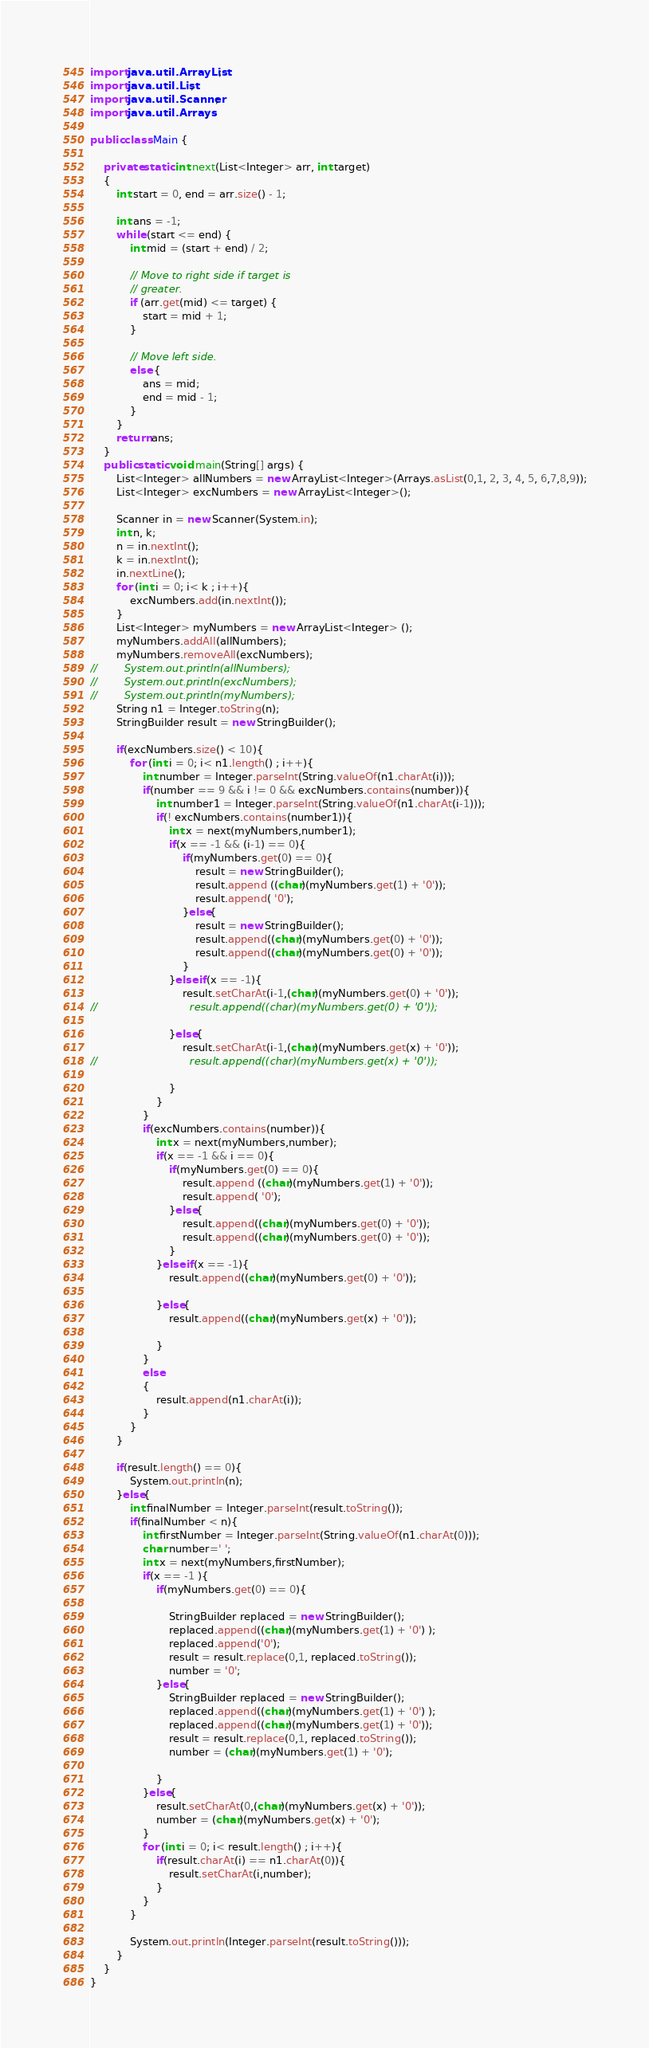Convert code to text. <code><loc_0><loc_0><loc_500><loc_500><_Java_>import java.util.ArrayList;
import java.util.List;
import java.util.Scanner;
import java.util.Arrays;

public class Main {

    private static int next(List<Integer> arr, int target)
    {
        int start = 0, end = arr.size() - 1;

        int ans = -1;
        while (start <= end) {
            int mid = (start + end) / 2;

            // Move to right side if target is
            // greater.
            if (arr.get(mid) <= target) {
                start = mid + 1;
            }

            // Move left side.
            else {
                ans = mid;
                end = mid - 1;
            }
        }
        return ans;
    }
    public static void main(String[] args) {
        List<Integer> allNumbers = new ArrayList<Integer>(Arrays.asList(0,1, 2, 3, 4, 5, 6,7,8,9));
        List<Integer> excNumbers = new ArrayList<Integer>();

        Scanner in = new Scanner(System.in);
        int n, k;
        n = in.nextInt();
        k = in.nextInt();
        in.nextLine();
        for (int i = 0; i< k ; i++){
            excNumbers.add(in.nextInt());
        }
        List<Integer> myNumbers = new ArrayList<Integer> ();
        myNumbers.addAll(allNumbers);
        myNumbers.removeAll(excNumbers);
//        System.out.println(allNumbers);
//        System.out.println(excNumbers);
//        System.out.println(myNumbers);
        String n1 = Integer.toString(n);
        StringBuilder result = new StringBuilder();

        if(excNumbers.size() < 10){
            for (int i = 0; i< n1.length() ; i++){
                int number = Integer.parseInt(String.valueOf(n1.charAt(i)));
                if(number == 9 && i != 0 && excNumbers.contains(number)){
                    int number1 = Integer.parseInt(String.valueOf(n1.charAt(i-1)));
                    if(! excNumbers.contains(number1)){
                        int x = next(myNumbers,number1);
                        if(x == -1 && (i-1) == 0){
                            if(myNumbers.get(0) == 0){
                                result = new StringBuilder();
                                result.append ((char)(myNumbers.get(1) + '0'));
                                result.append( '0');
                            }else{
                                result = new StringBuilder();
                                result.append((char)(myNumbers.get(0) + '0'));
                                result.append((char)(myNumbers.get(0) + '0'));
                            }
                        }else if(x == -1){
                            result.setCharAt(i-1,(char)(myNumbers.get(0) + '0'));
//                            result.append((char)(myNumbers.get(0) + '0'));

                        }else{
                            result.setCharAt(i-1,(char)(myNumbers.get(x) + '0'));
//                            result.append((char)(myNumbers.get(x) + '0'));

                        }
                    }
                }
                if(excNumbers.contains(number)){
                    int x = next(myNumbers,number);
                    if(x == -1 && i == 0){
                        if(myNumbers.get(0) == 0){
                            result.append ((char)(myNumbers.get(1) + '0'));
                            result.append( '0');
                        }else{
                            result.append((char)(myNumbers.get(0) + '0'));
                            result.append((char)(myNumbers.get(0) + '0'));
                        }
                    }else if(x == -1){
                        result.append((char)(myNumbers.get(0) + '0'));

                    }else{
                        result.append((char)(myNumbers.get(x) + '0'));

                    }
                }
                else
                {
                    result.append(n1.charAt(i));
                }
            }
        }

        if(result.length() == 0){
            System.out.println(n);
        }else{
            int finalNumber = Integer.parseInt(result.toString());
            if(finalNumber < n){
                int firstNumber = Integer.parseInt(String.valueOf(n1.charAt(0)));
                char number=' ';
                int x = next(myNumbers,firstNumber);
                if(x == -1 ){
                    if(myNumbers.get(0) == 0){

                        StringBuilder replaced = new StringBuilder();
                        replaced.append((char)(myNumbers.get(1) + '0') );
                        replaced.append('0');
                        result = result.replace(0,1, replaced.toString());
                        number = '0';
                    }else{
                        StringBuilder replaced = new StringBuilder();
                        replaced.append((char)(myNumbers.get(1) + '0') );
                        replaced.append((char)(myNumbers.get(1) + '0'));
                        result = result.replace(0,1, replaced.toString());
                        number = (char)(myNumbers.get(1) + '0');

                    }
                }else{
                    result.setCharAt(0,(char)(myNumbers.get(x) + '0'));
                    number = (char)(myNumbers.get(x) + '0');
                }
                for (int i = 0; i< result.length() ; i++){
                    if(result.charAt(i) == n1.charAt(0)){
                        result.setCharAt(i,number);
                    }
                }
            }

            System.out.println(Integer.parseInt(result.toString()));
        }
    }
}
</code> 